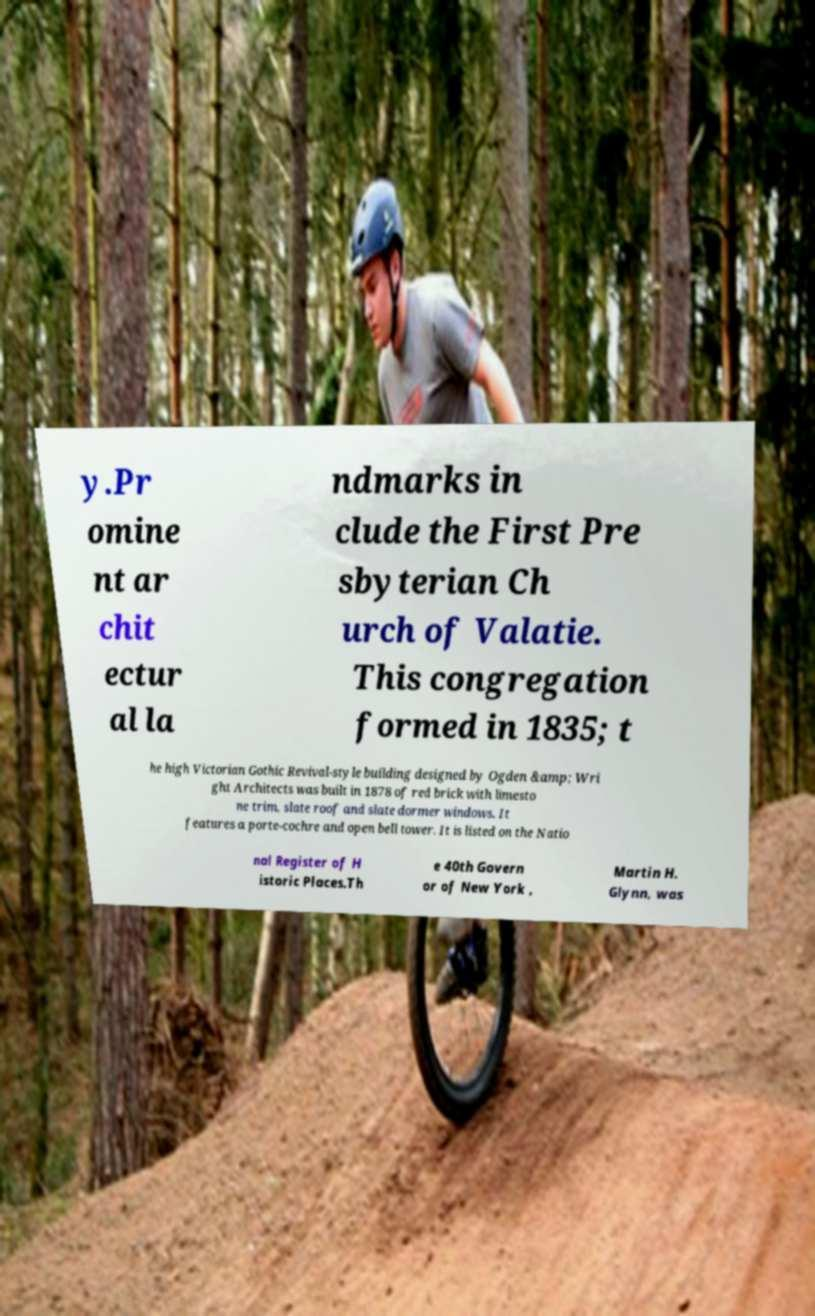Can you accurately transcribe the text from the provided image for me? y.Pr omine nt ar chit ectur al la ndmarks in clude the First Pre sbyterian Ch urch of Valatie. This congregation formed in 1835; t he high Victorian Gothic Revival-style building designed by Ogden &amp; Wri ght Architects was built in 1878 of red brick with limesto ne trim, slate roof and slate dormer windows. It features a porte-cochre and open bell tower. It is listed on the Natio nal Register of H istoric Places.Th e 40th Govern or of New York , Martin H. Glynn, was 